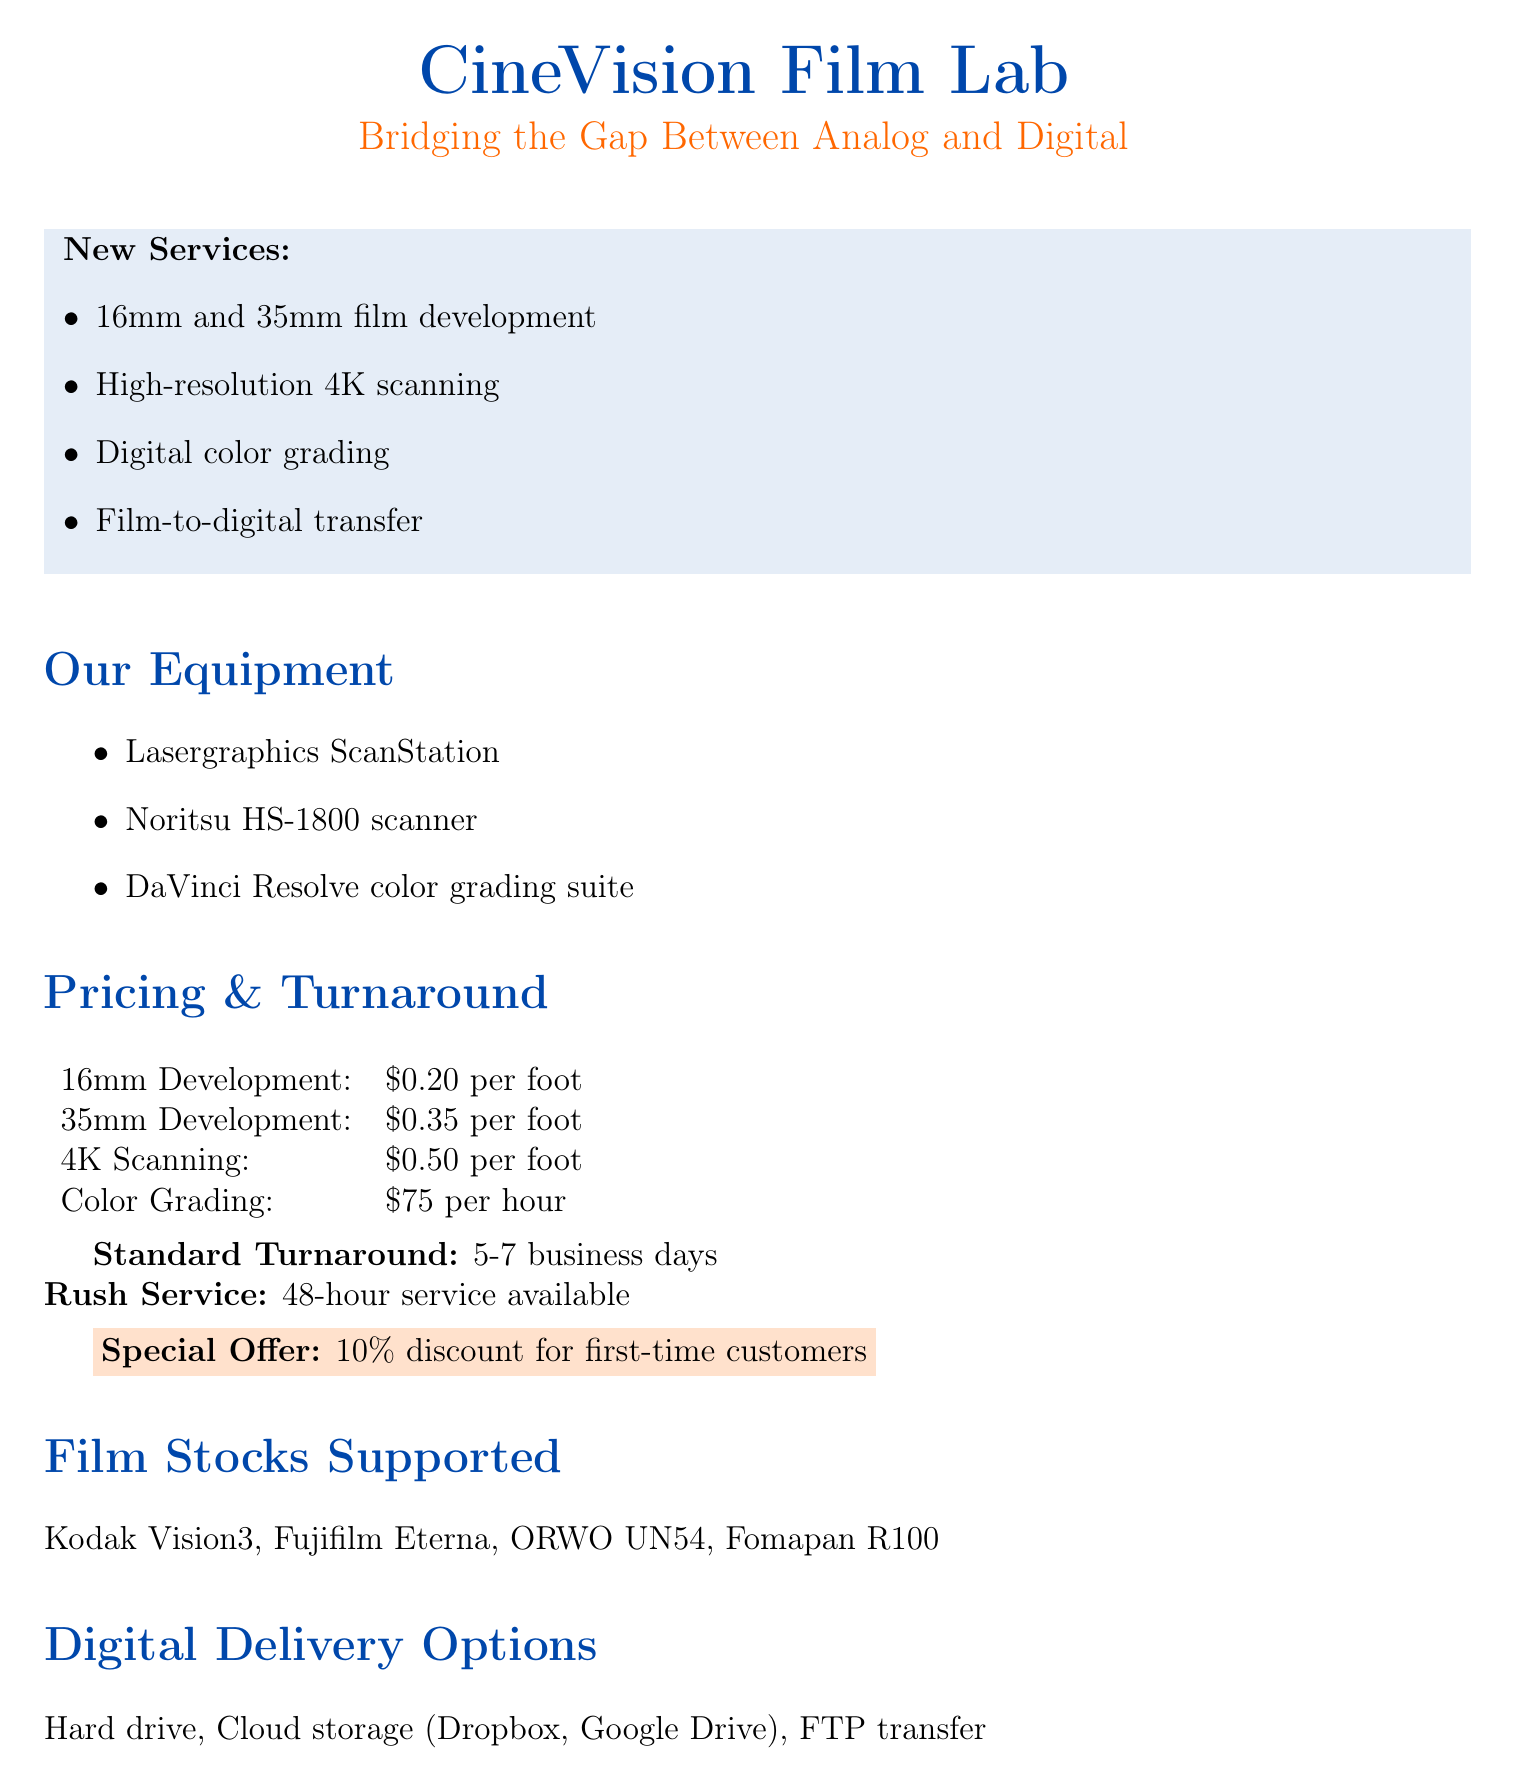What new services are offered? The document lists new services, which include 16mm and 35mm film development, high-resolution 4K scanning, digital color grading, and film-to-digital transfer.
Answer: 16mm and 35mm film development, high-resolution 4K scanning, digital color grading, film-to-digital transfer What is the price for 35mm development? Pricing information reveals that the cost for 35mm development is specified.
Answer: $0.35 per foot What is the turnaround time for rush service? The document outlines that rush service has a specific turnaround time.
Answer: 48-hour service available What digital delivery options are provided? The document mentions several methods for digital delivery of finished films.
Answer: Hard drive, Cloud storage (Dropbox, Google Drive), FTP transfer What initiative focuses on environmental sustainability? The document lists sustainability initiatives, including eco-friendly practices.
Answer: Eco-friendly chemical disposal How much is the discount for first-time customers? The special offer provided in the document specifies the discount rate.
Answer: 10% discount Which film stocks are supported? The document details the various film stocks that the lab can process.
Answer: Kodak Vision3, Fujifilm Eterna, ORWO UN54, Fomapan R100 What equipment is used for scanning? The document specifies the equipment used for scanning films.
Answer: Lasergraphics ScanStation, Noritsu HS-1800 scanner What is the hourly rate for color grading? The pricing section includes the rate for color grading services.
Answer: $75 per hour 